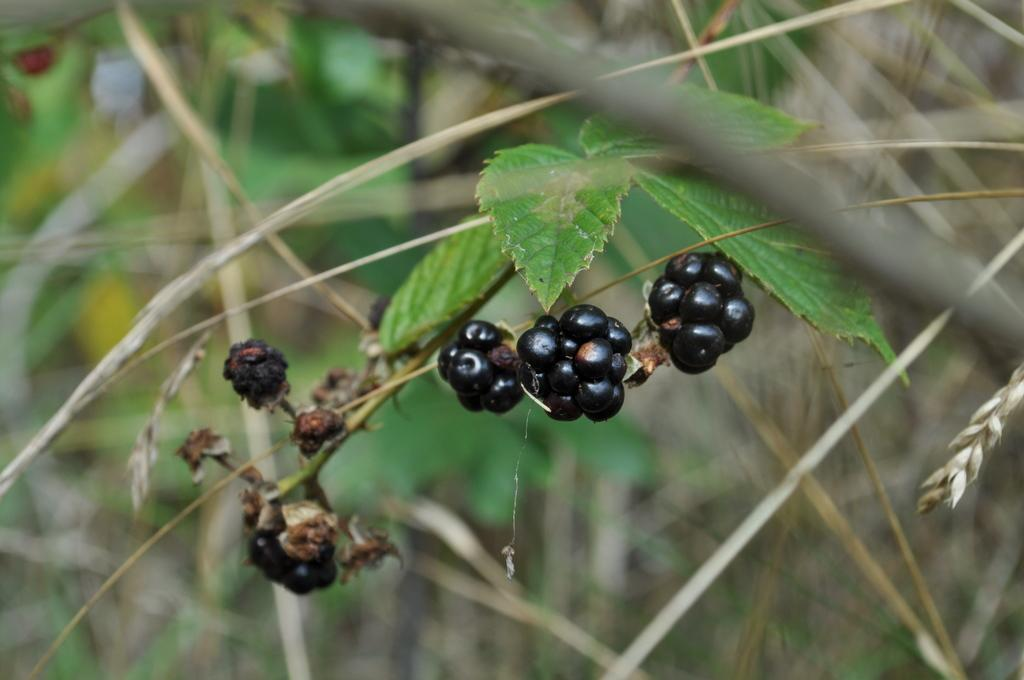What type of plants are visible in the image? There are trees with fruits in the image. Can you describe the background of the image? The background of the image is blurred. What type of yam is being used to cause a reaction in the children in the image? There is no yam or children present in the image; it only features trees with fruits and a blurred background. 